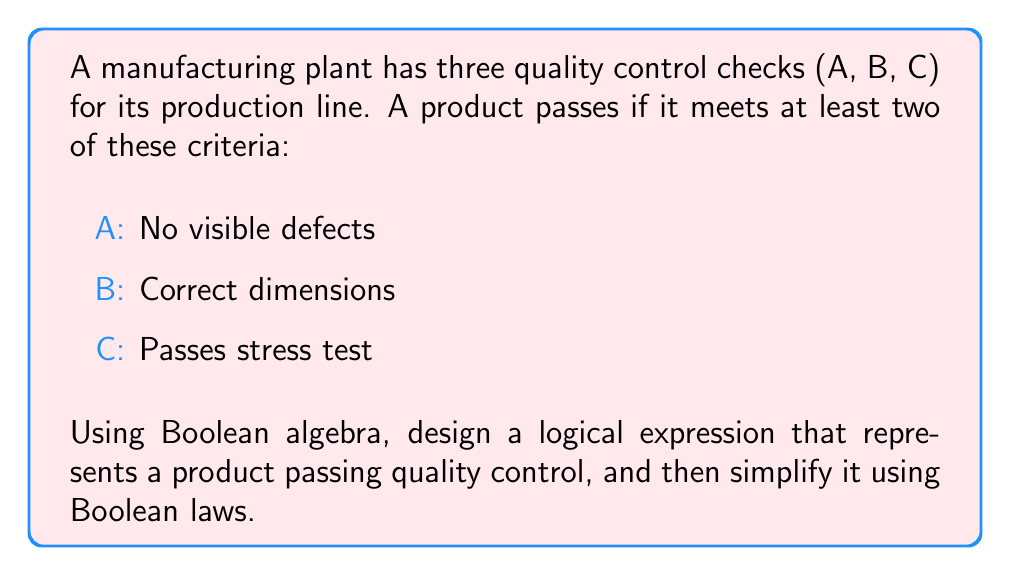Can you answer this question? Let's approach this step-by-step:

1) First, we need to represent each quality control check as a Boolean variable:
   A: No visible defects (1 if true, 0 if false)
   B: Correct dimensions (1 if true, 0 if false)
   C: Passes stress test (1 if true, 0 if false)

2) A product passes if it meets at least two criteria. We can represent this as:

   $$(A \wedge B) \vee (A \wedge C) \vee (B \wedge C)$$

3) This expression represents all possible combinations where at least two criteria are met.

4) We can simplify this expression using Boolean algebra laws:

   $$(A \wedge B) \vee (A \wedge C) \vee (B \wedge C)$$
   
   $$= A \wedge (B \vee C) \vee (B \wedge C)$$ (Distributive Law)
   
   $$= (A \wedge B) \vee (A \wedge C) \vee (B \wedge C)$$ (Distributive Law again)

5) This is our simplified expression. It's worth noting that this simplification doesn't reduce the number of terms, but it does provide an alternative representation that might be useful in certain contexts.

6) In terms of efficiency, this logical expression allows the quality control system to pass a product as soon as it meets any two criteria, without necessarily checking the third if not needed.
Answer: $$(A \wedge B) \vee (A \wedge C) \vee (B \wedge C)$$ 